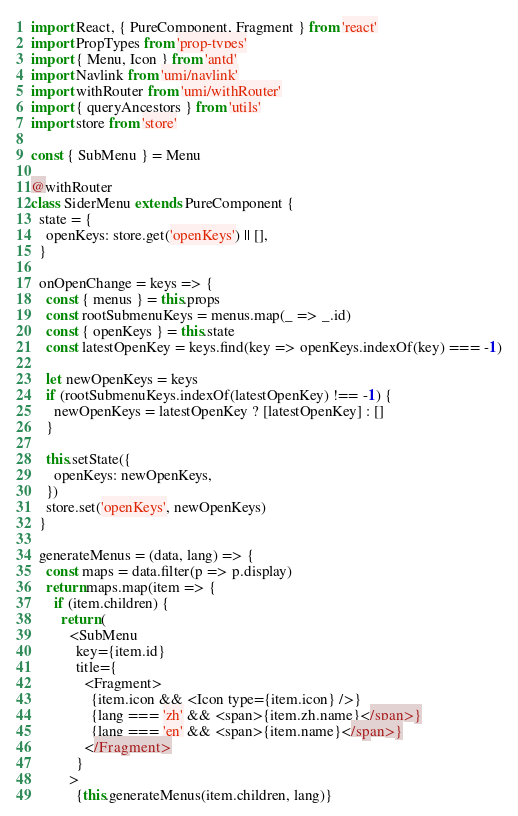Convert code to text. <code><loc_0><loc_0><loc_500><loc_500><_JavaScript_>import React, { PureComponent, Fragment } from 'react'
import PropTypes from 'prop-types'
import { Menu, Icon } from 'antd'
import Navlink from 'umi/navlink'
import withRouter from 'umi/withRouter'
import { queryAncestors } from 'utils'
import store from 'store'

const { SubMenu } = Menu

@withRouter
class SiderMenu extends PureComponent {
  state = {
    openKeys: store.get('openKeys') || [],
  }

  onOpenChange = keys => {
    const { menus } = this.props
    const rootSubmenuKeys = menus.map(_ => _.id)
    const { openKeys } = this.state
    const latestOpenKey = keys.find(key => openKeys.indexOf(key) === -1)

    let newOpenKeys = keys
    if (rootSubmenuKeys.indexOf(latestOpenKey) !== -1) {
      newOpenKeys = latestOpenKey ? [latestOpenKey] : []
    }

    this.setState({
      openKeys: newOpenKeys,
    })
    store.set('openKeys', newOpenKeys)
  }

  generateMenus = (data, lang) => {
    const maps = data.filter(p => p.display)
    return maps.map(item => {
      if (item.children) {
        return (
          <SubMenu
            key={item.id}
            title={
              <Fragment>
                {item.icon && <Icon type={item.icon} />}
                {lang === 'zh' && <span>{item.zh.name}</span>}
                {lang === 'en' && <span>{item.name}</span>}
              </Fragment>
            }
          >
            {this.generateMenus(item.children, lang)}</code> 